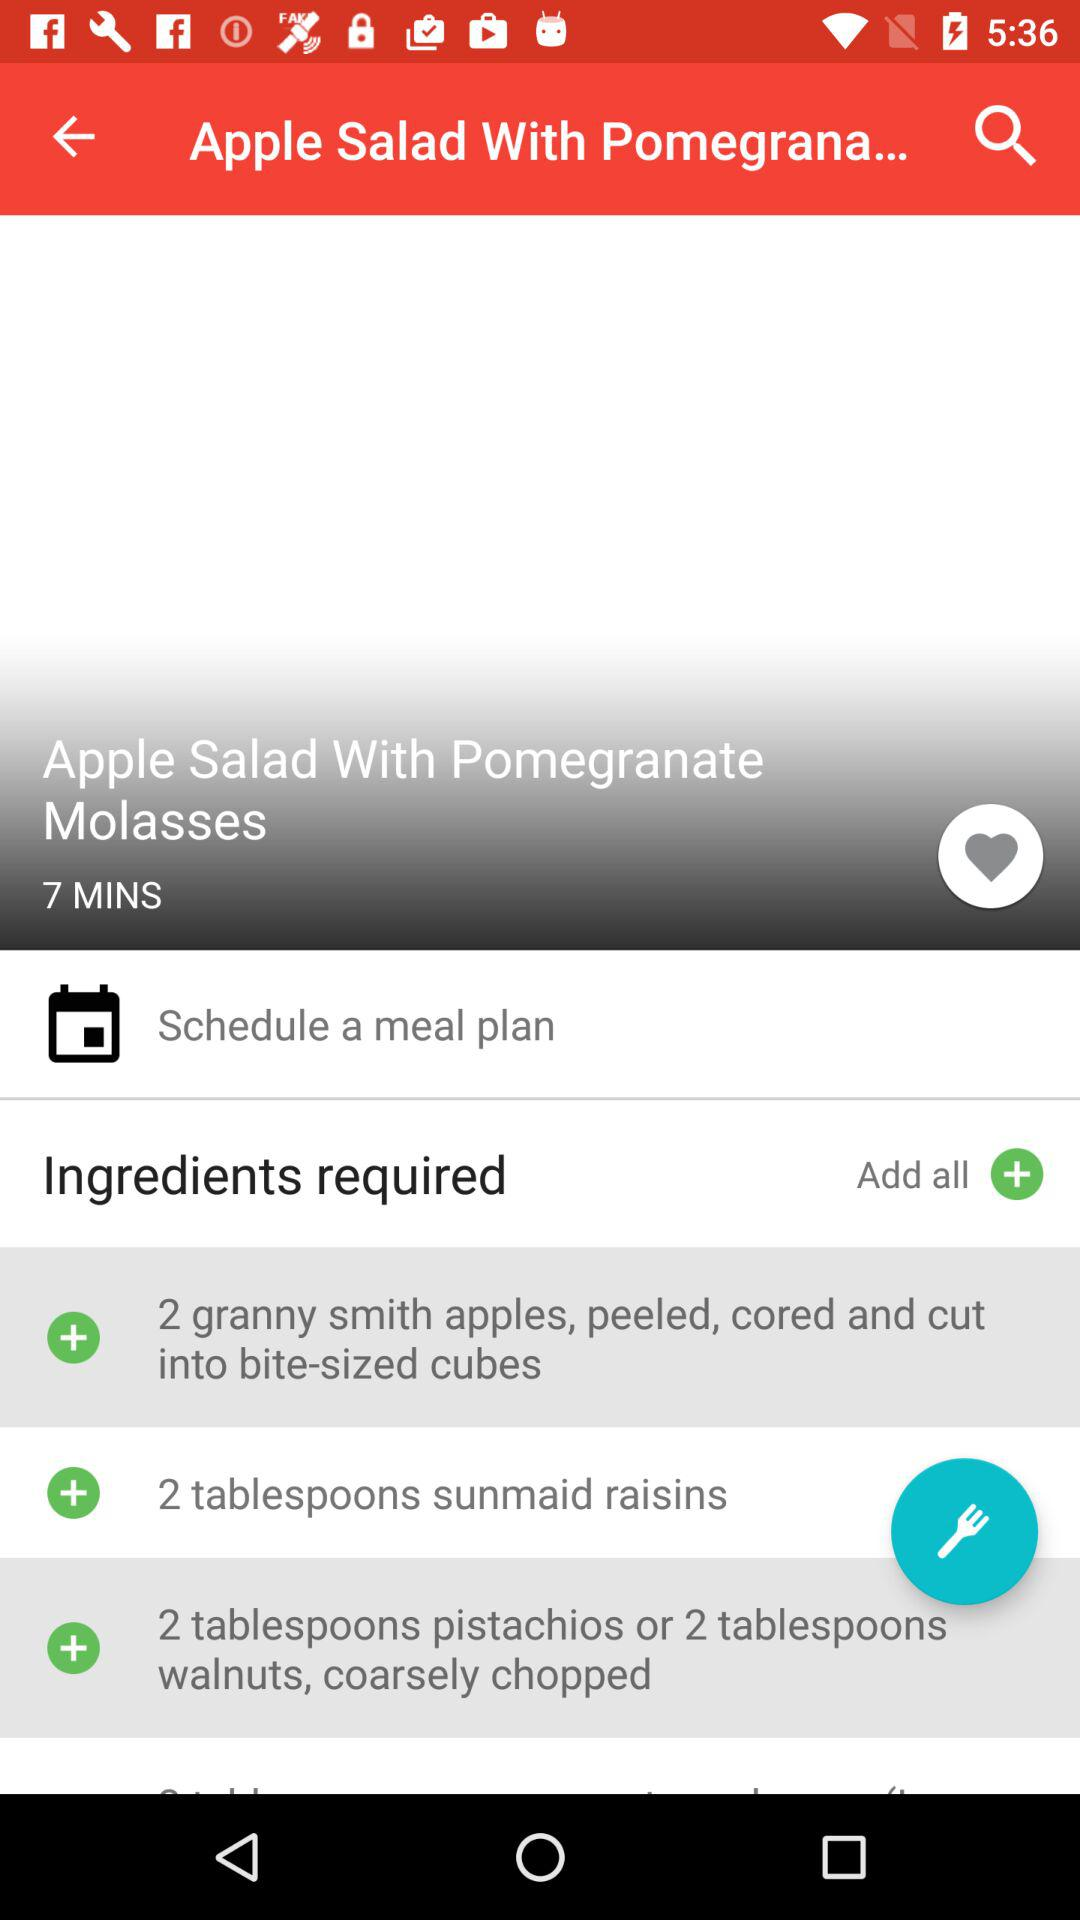How many tablespoons of sunmaid raisins are required? There are two tablespoons of sunmaid raisins required. 